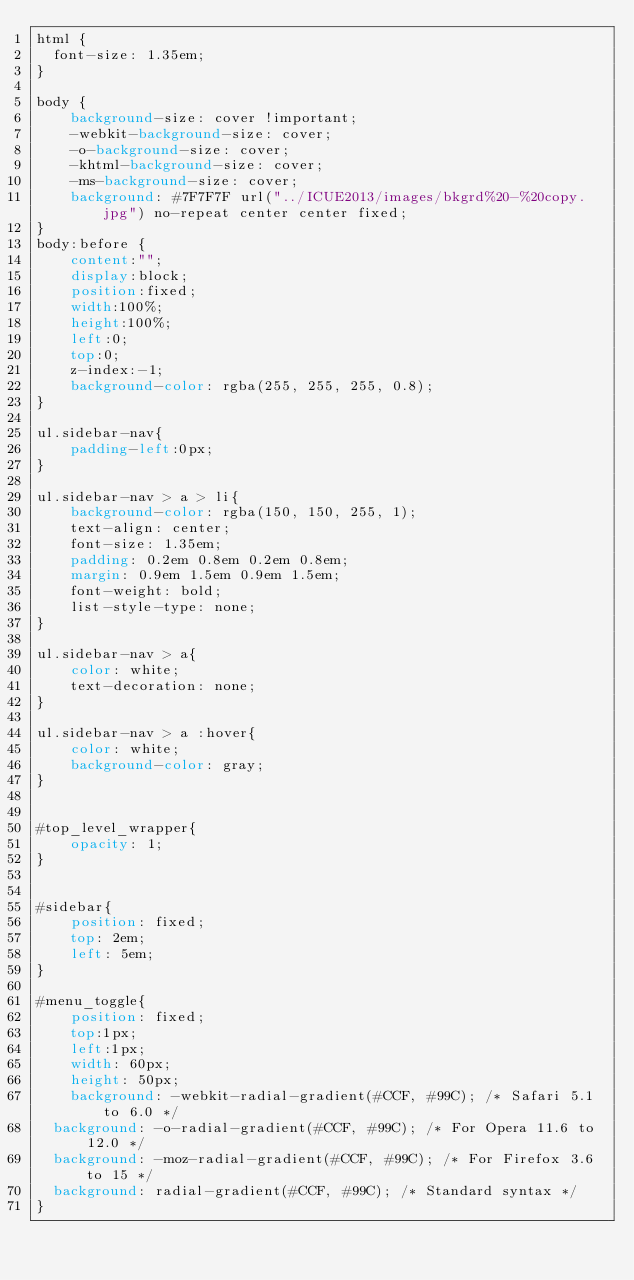<code> <loc_0><loc_0><loc_500><loc_500><_CSS_>html {
  font-size: 1.35em;
}

body {
    background-size: cover !important;
	-webkit-background-size: cover;
	-o-background-size: cover;
	-khtml-background-size: cover;
	-ms-background-size: cover;
	background: #7F7F7F url("../ICUE2013/images/bkgrd%20-%20copy.jpg") no-repeat center center fixed;
}
body:before {
    content:"";
    display:block;
    position:fixed;
    width:100%;
    height:100%;
    left:0;
    top:0;
    z-index:-1;
    background-color: rgba(255, 255, 255, 0.8);
}

ul.sidebar-nav{
    padding-left:0px;
}

ul.sidebar-nav > a > li{
    background-color: rgba(150, 150, 255, 1);
    text-align: center;
    font-size: 1.35em;
    padding: 0.2em 0.8em 0.2em 0.8em;
    margin: 0.9em 1.5em 0.9em 1.5em;
    font-weight: bold;
    list-style-type: none;
}

ul.sidebar-nav > a{
    color: white;
    text-decoration: none;
}

ul.sidebar-nav > a :hover{
    color: white;
    background-color: gray;
}


#top_level_wrapper{
    opacity: 1;
}


#sidebar{
    position: fixed;
    top: 2em;
    left: 5em;
}

#menu_toggle{
    position: fixed;
    top:1px;
    left:1px;
    width: 60px;
    height: 50px;
    background: -webkit-radial-gradient(#CCF, #99C); /* Safari 5.1 to 6.0 */
  background: -o-radial-gradient(#CCF, #99C); /* For Opera 11.6 to 12.0 */
  background: -moz-radial-gradient(#CCF, #99C); /* For Firefox 3.6 to 15 */
  background: radial-gradient(#CCF, #99C); /* Standard syntax */
}
</code> 